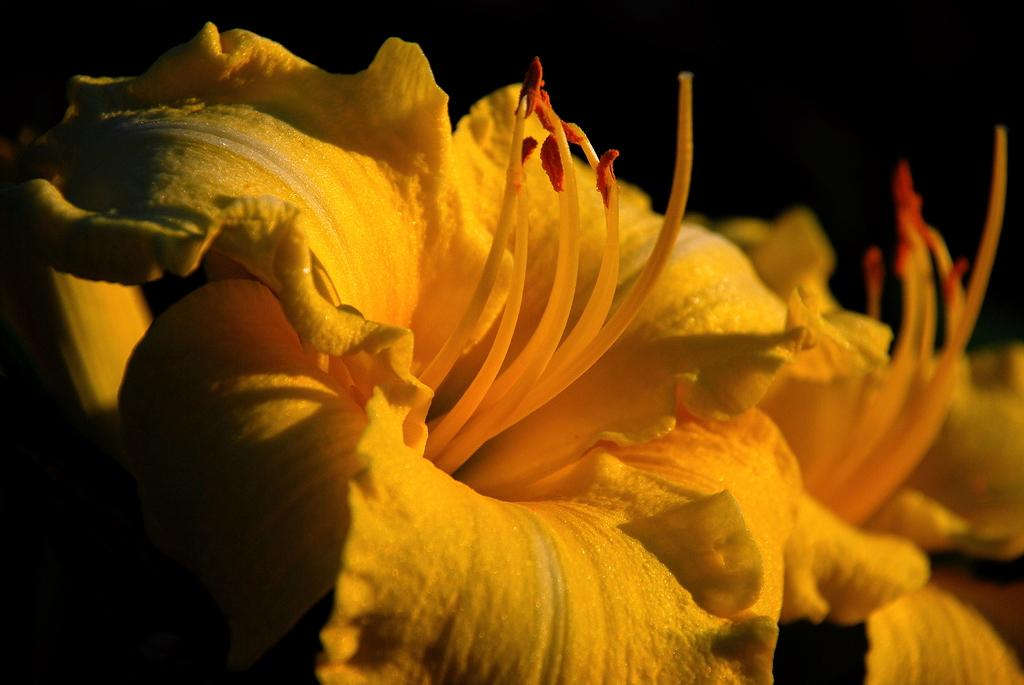What type of living organisms can be seen in the image? Flowers can be seen in the image. What type of frame is visible around the flowers in the image? There is no frame visible around the flowers in the image; it is a simple image of flowers. What type of tail can be seen attached to the flowers in the image? There are no tails present in the image, as it features flowers. 